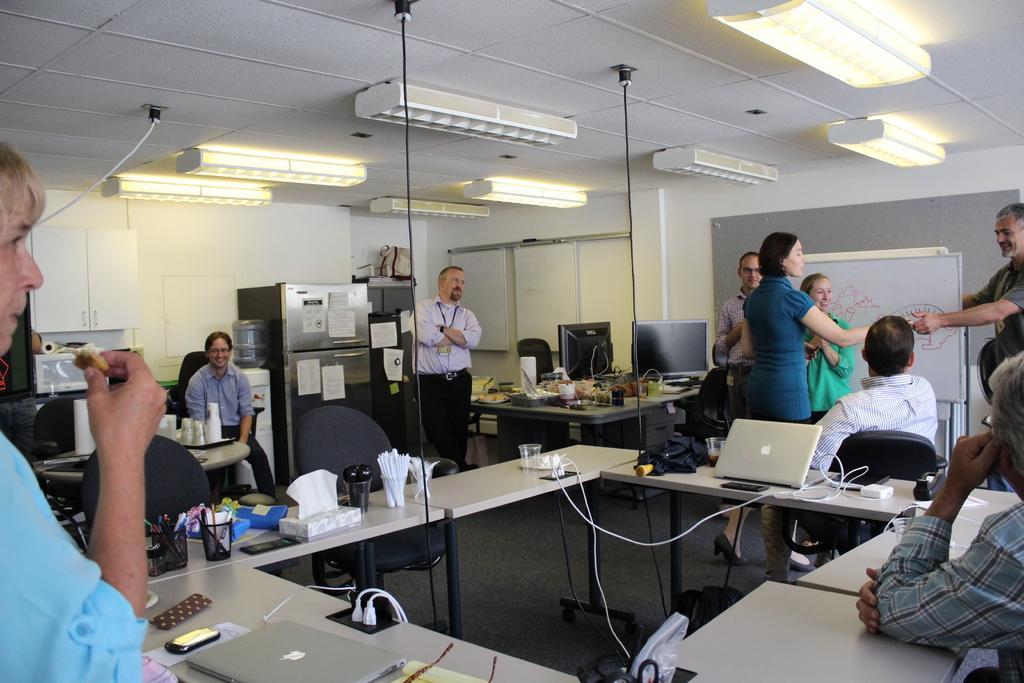Please provide a concise description of this image. In this image I can see number of people where few of them are sitting on chairs and red all are standing. On these tables I can see few laptops, glasses and few more stuffs. 